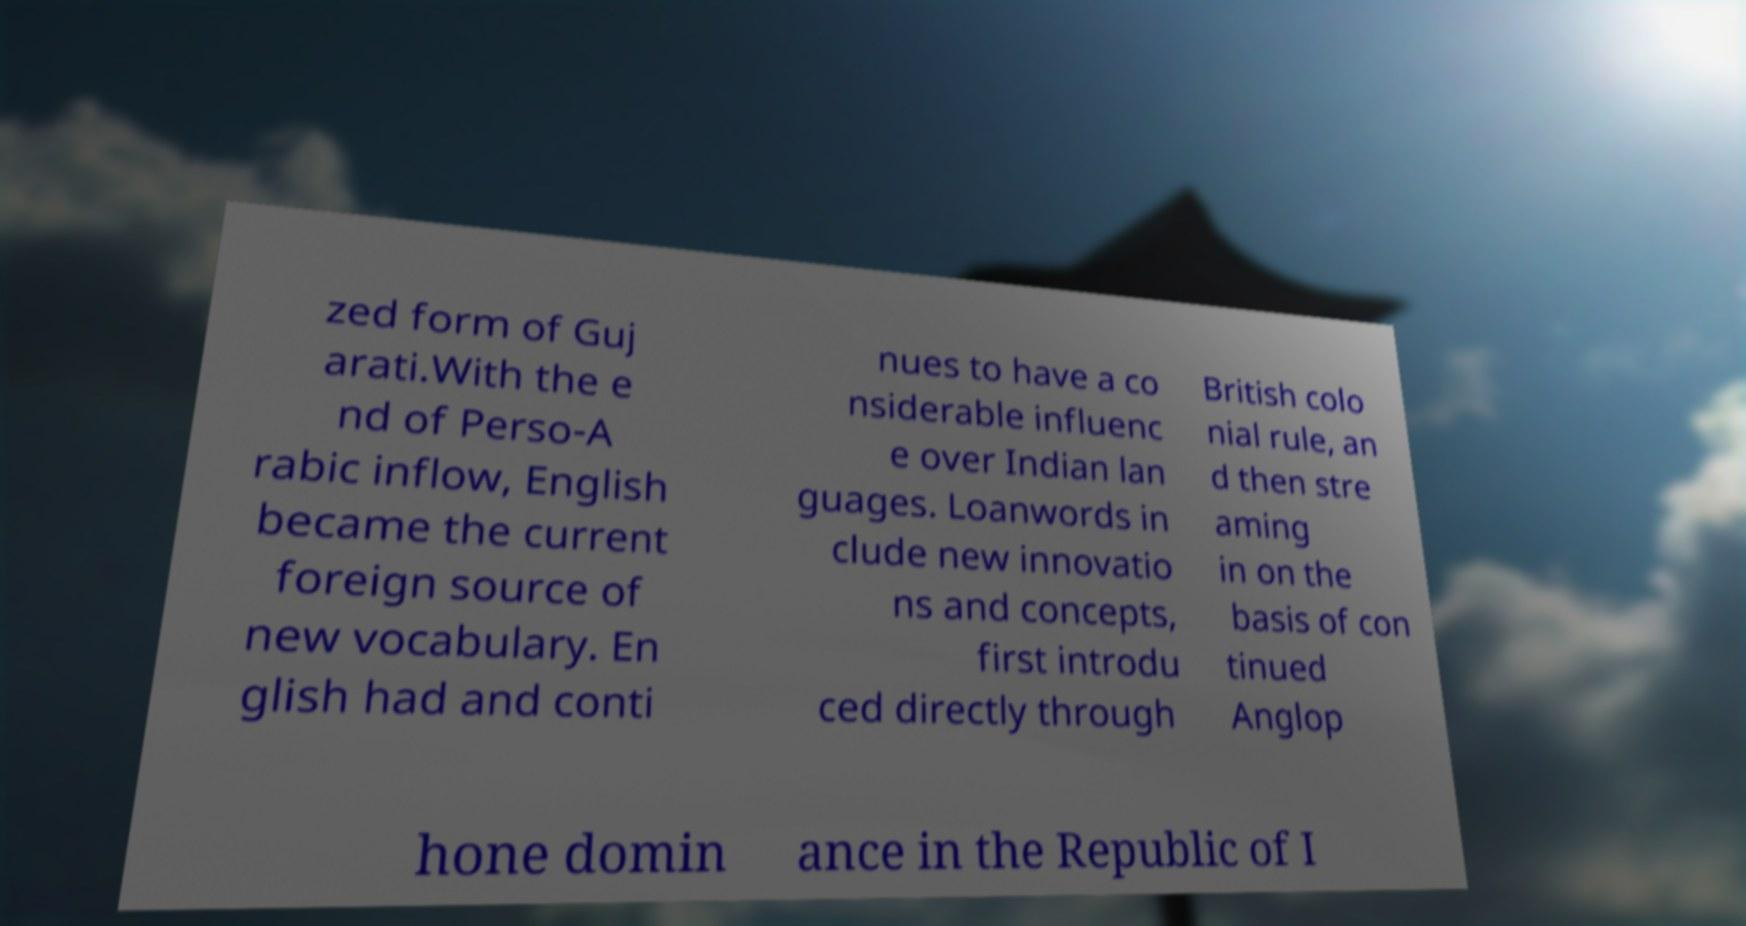What messages or text are displayed in this image? I need them in a readable, typed format. zed form of Guj arati.With the e nd of Perso-A rabic inflow, English became the current foreign source of new vocabulary. En glish had and conti nues to have a co nsiderable influenc e over Indian lan guages. Loanwords in clude new innovatio ns and concepts, first introdu ced directly through British colo nial rule, an d then stre aming in on the basis of con tinued Anglop hone domin ance in the Republic of I 